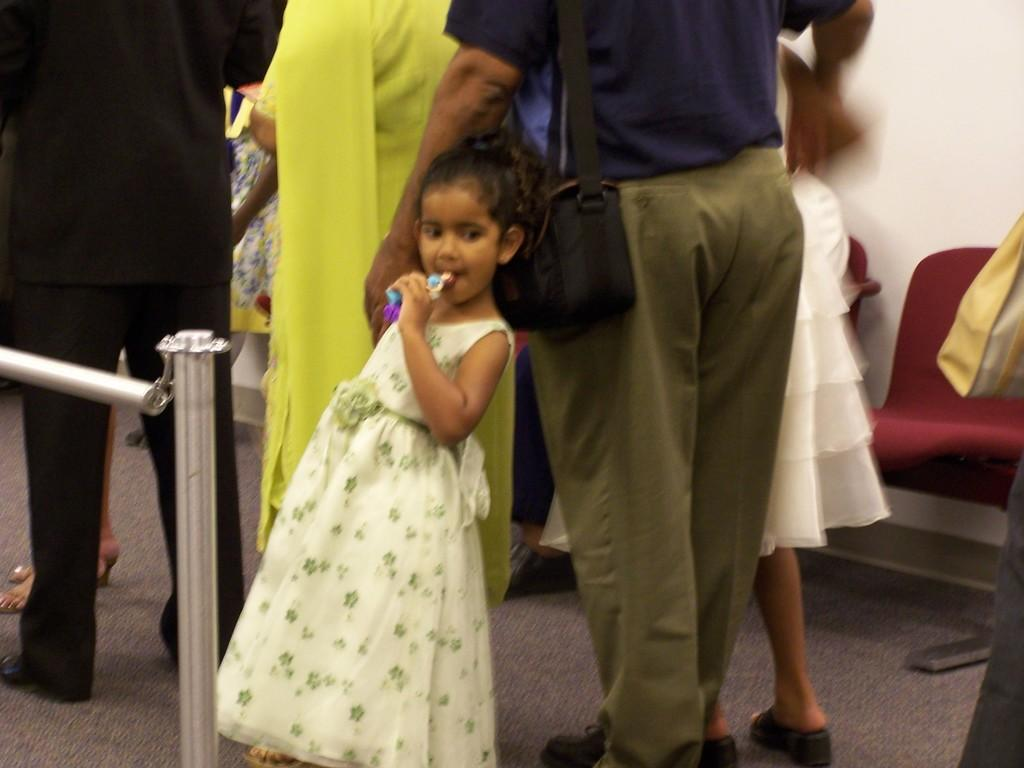How many people are in the image? There are people in the image, but the exact number is not specified. What is the girl in the center of the image doing? The girl is standing in the center of the image and holding an object. What can be seen on the left side of the image? There is a railing on the left side of the image. What is visible in the background of the image? Chairs and a wall are present in the background of the image. What type of field can be seen in the image? There is no field present in the image. What is the girl's mind thinking about in the image? The girl's thoughts or mental state cannot be determined from the image. 